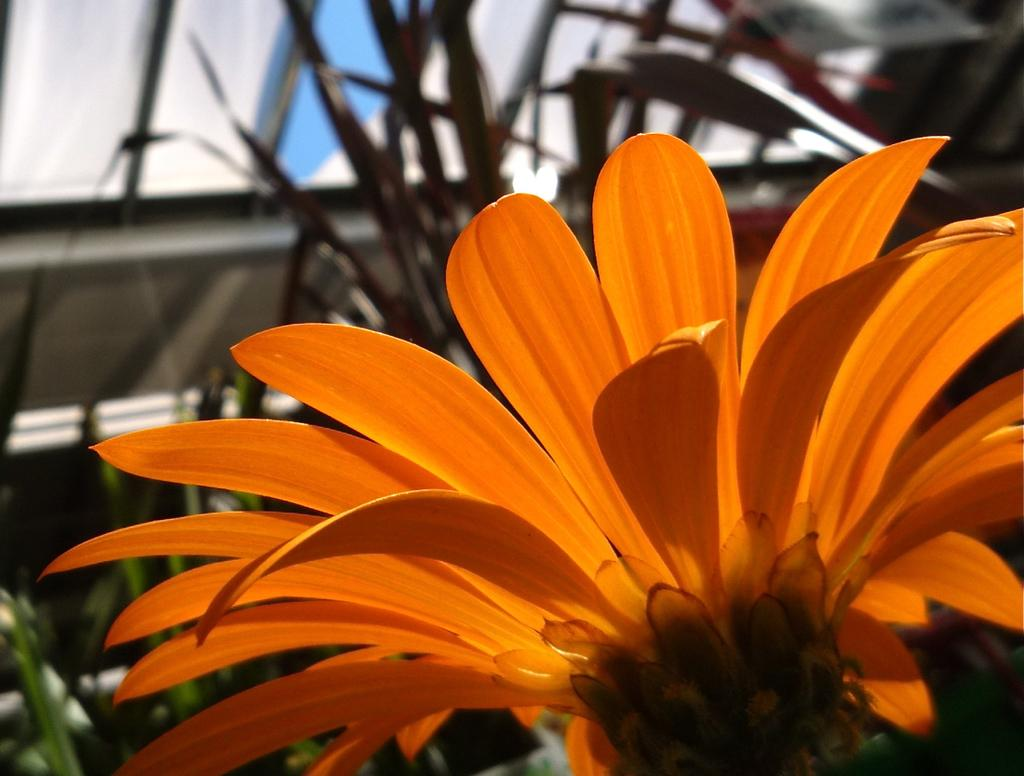What color is the flower in the image? The flower in the image is orange. What type of vegetation can be seen in the background of the image? There is grass visible in the background of the image. Can you describe the object in the background of the image? Unfortunately, the facts provided do not give enough information to describe the object in the background. What type of coal is being used to fuel the whistle in the image? There is no coal or whistle present in the image; it features an orange flower and grass in the background. 